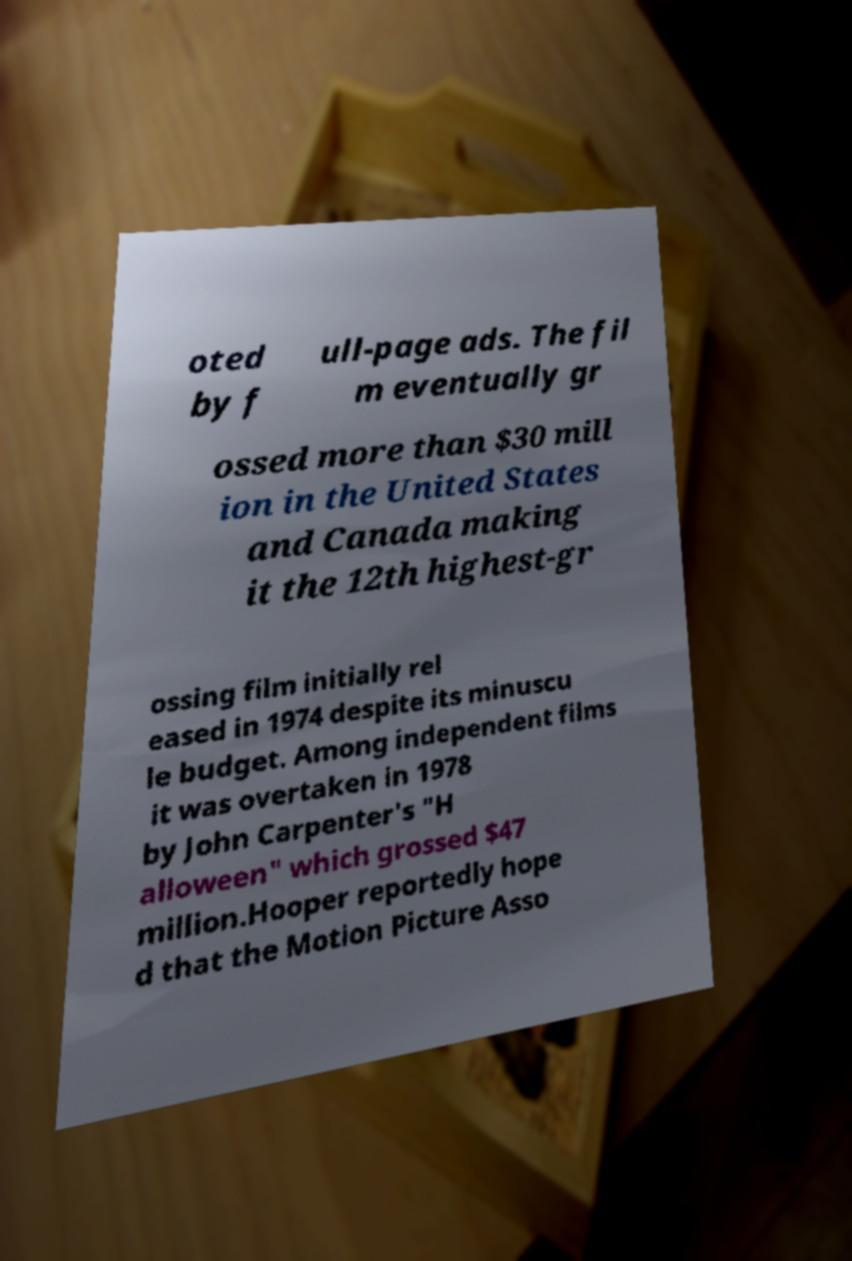There's text embedded in this image that I need extracted. Can you transcribe it verbatim? oted by f ull-page ads. The fil m eventually gr ossed more than $30 mill ion in the United States and Canada making it the 12th highest-gr ossing film initially rel eased in 1974 despite its minuscu le budget. Among independent films it was overtaken in 1978 by John Carpenter's "H alloween" which grossed $47 million.Hooper reportedly hope d that the Motion Picture Asso 